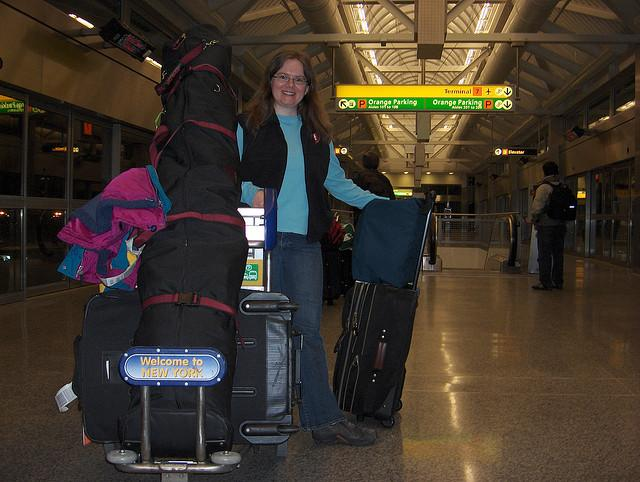What is the woman likely to use to get back home? airplane 